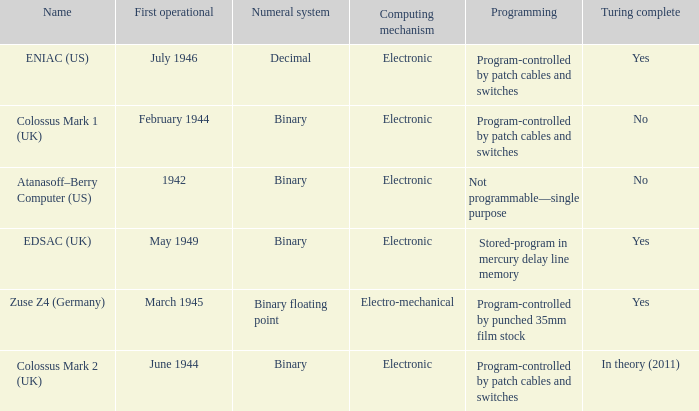What's the turing complete with name being atanasoff–berry computer (us) No. 